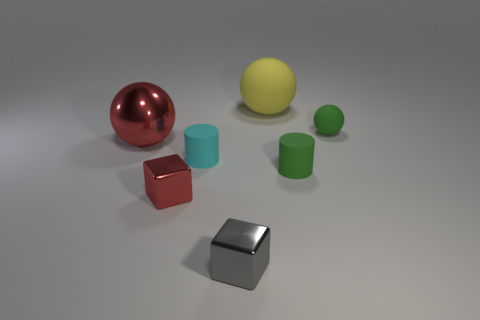There is a green matte thing that is in front of the large object on the left side of the tiny metal block in front of the small red block; what is its size?
Your response must be concise. Small. What shape is the cyan matte thing that is the same size as the gray object?
Your answer should be compact. Cylinder. What is the shape of the small gray thing?
Make the answer very short. Cube. Do the big ball that is in front of the yellow rubber object and the red cube have the same material?
Offer a very short reply. Yes. How big is the green rubber object to the right of the green cylinder that is in front of the cyan thing?
Ensure brevity in your answer.  Small. The shiny thing that is to the right of the large red metallic thing and behind the tiny gray thing is what color?
Offer a very short reply. Red. There is a red cube that is the same size as the gray thing; what is its material?
Your answer should be very brief. Metal. What number of other objects are there of the same material as the small sphere?
Your answer should be compact. 3. There is a cube that is to the left of the small cyan matte object; does it have the same color as the ball that is left of the tiny gray shiny thing?
Make the answer very short. Yes. The tiny rubber object that is on the right side of the rubber cylinder in front of the small cyan cylinder is what shape?
Provide a succinct answer. Sphere. 